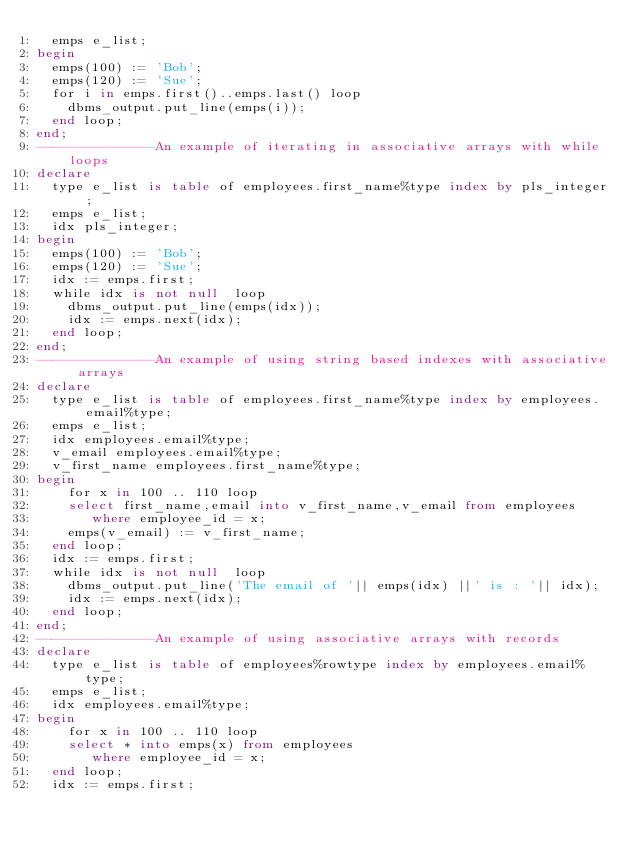<code> <loc_0><loc_0><loc_500><loc_500><_SQL_>  emps e_list;
begin
  emps(100) := 'Bob';
  emps(120) := 'Sue';
  for i in emps.first()..emps.last() loop
    dbms_output.put_line(emps(i));
  end loop;
end;
---------------An example of iterating in associative arrays with while loops
declare
  type e_list is table of employees.first_name%type index by pls_integer;
  emps e_list;
  idx pls_integer;
begin
  emps(100) := 'Bob';
  emps(120) := 'Sue';
  idx := emps.first;
  while idx is not null  loop
    dbms_output.put_line(emps(idx));
    idx := emps.next(idx);
  end loop;
end;
---------------An example of using string based indexes with associative arrays
declare
  type e_list is table of employees.first_name%type index by employees.email%type;
  emps e_list;
  idx employees.email%type;
  v_email employees.email%type;
  v_first_name employees.first_name%type;
begin
    for x in 100 .. 110 loop
    select first_name,email into v_first_name,v_email from employees
       where employee_id = x;
    emps(v_email) := v_first_name;
  end loop;
  idx := emps.first;
  while idx is not null  loop
    dbms_output.put_line('The email of '|| emps(idx) ||' is : '|| idx);
    idx := emps.next(idx);
  end loop;
end;
---------------An example of using associative arrays with records
declare
  type e_list is table of employees%rowtype index by employees.email%type;
  emps e_list;
  idx employees.email%type;
begin
    for x in 100 .. 110 loop
    select * into emps(x) from employees
       where employee_id = x;
  end loop;
  idx := emps.first;</code> 